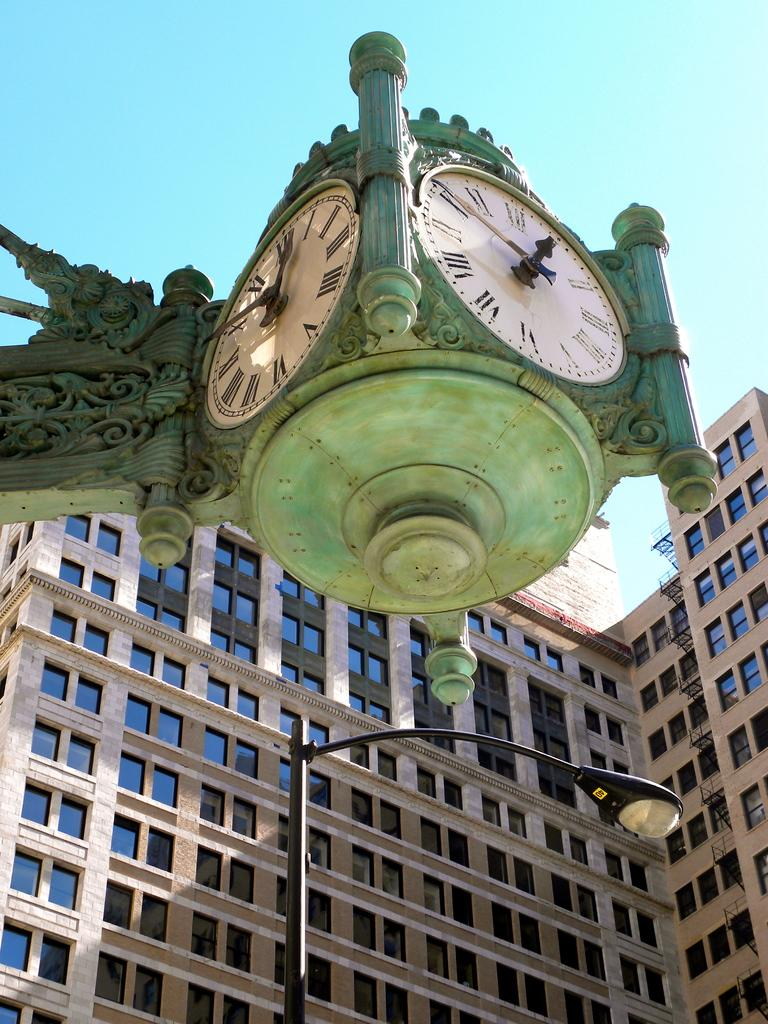<image>
Render a clear and concise summary of the photo. The current time in this town is approximately 12:50. 